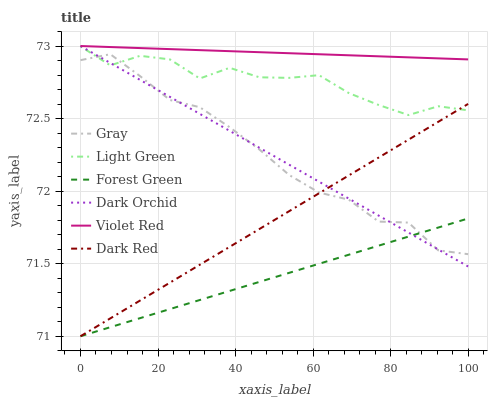Does Forest Green have the minimum area under the curve?
Answer yes or no. Yes. Does Violet Red have the maximum area under the curve?
Answer yes or no. Yes. Does Dark Red have the minimum area under the curve?
Answer yes or no. No. Does Dark Red have the maximum area under the curve?
Answer yes or no. No. Is Violet Red the smoothest?
Answer yes or no. Yes. Is Light Green the roughest?
Answer yes or no. Yes. Is Dark Red the smoothest?
Answer yes or no. No. Is Dark Red the roughest?
Answer yes or no. No. Does Dark Red have the lowest value?
Answer yes or no. Yes. Does Violet Red have the lowest value?
Answer yes or no. No. Does Dark Orchid have the highest value?
Answer yes or no. Yes. Does Dark Red have the highest value?
Answer yes or no. No. Is Forest Green less than Violet Red?
Answer yes or no. Yes. Is Light Green greater than Forest Green?
Answer yes or no. Yes. Does Gray intersect Forest Green?
Answer yes or no. Yes. Is Gray less than Forest Green?
Answer yes or no. No. Is Gray greater than Forest Green?
Answer yes or no. No. Does Forest Green intersect Violet Red?
Answer yes or no. No. 